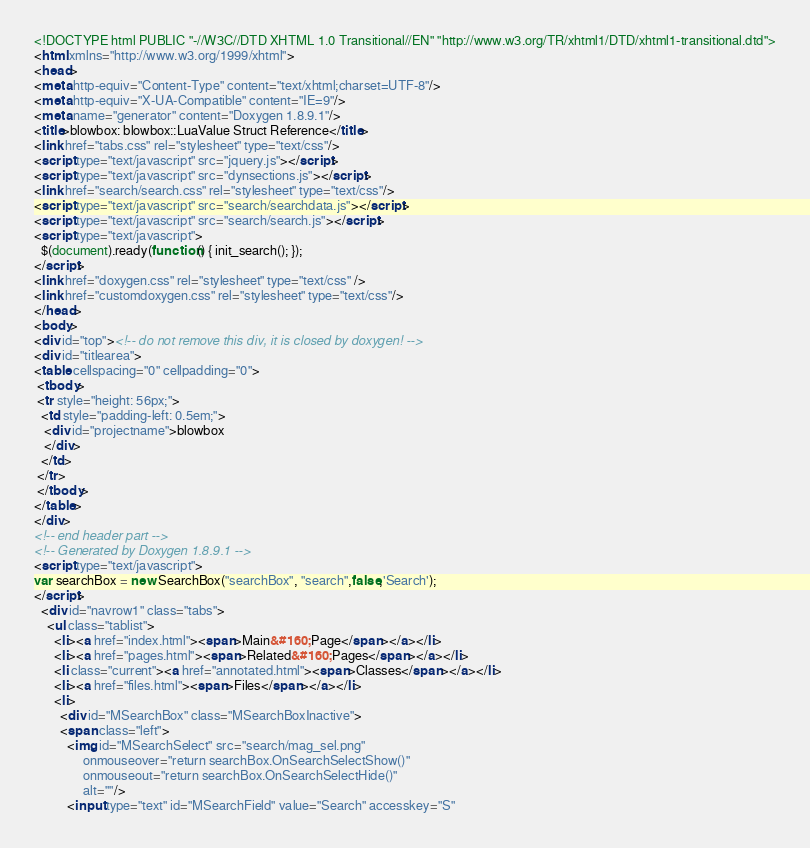Convert code to text. <code><loc_0><loc_0><loc_500><loc_500><_HTML_><!DOCTYPE html PUBLIC "-//W3C//DTD XHTML 1.0 Transitional//EN" "http://www.w3.org/TR/xhtml1/DTD/xhtml1-transitional.dtd">
<html xmlns="http://www.w3.org/1999/xhtml">
<head>
<meta http-equiv="Content-Type" content="text/xhtml;charset=UTF-8"/>
<meta http-equiv="X-UA-Compatible" content="IE=9"/>
<meta name="generator" content="Doxygen 1.8.9.1"/>
<title>blowbox: blowbox::LuaValue Struct Reference</title>
<link href="tabs.css" rel="stylesheet" type="text/css"/>
<script type="text/javascript" src="jquery.js"></script>
<script type="text/javascript" src="dynsections.js"></script>
<link href="search/search.css" rel="stylesheet" type="text/css"/>
<script type="text/javascript" src="search/searchdata.js"></script>
<script type="text/javascript" src="search/search.js"></script>
<script type="text/javascript">
  $(document).ready(function() { init_search(); });
</script>
<link href="doxygen.css" rel="stylesheet" type="text/css" />
<link href="customdoxygen.css" rel="stylesheet" type="text/css"/>
</head>
<body>
<div id="top"><!-- do not remove this div, it is closed by doxygen! -->
<div id="titlearea">
<table cellspacing="0" cellpadding="0">
 <tbody>
 <tr style="height: 56px;">
  <td style="padding-left: 0.5em;">
   <div id="projectname">blowbox
   </div>
  </td>
 </tr>
 </tbody>
</table>
</div>
<!-- end header part -->
<!-- Generated by Doxygen 1.8.9.1 -->
<script type="text/javascript">
var searchBox = new SearchBox("searchBox", "search",false,'Search');
</script>
  <div id="navrow1" class="tabs">
    <ul class="tablist">
      <li><a href="index.html"><span>Main&#160;Page</span></a></li>
      <li><a href="pages.html"><span>Related&#160;Pages</span></a></li>
      <li class="current"><a href="annotated.html"><span>Classes</span></a></li>
      <li><a href="files.html"><span>Files</span></a></li>
      <li>
        <div id="MSearchBox" class="MSearchBoxInactive">
        <span class="left">
          <img id="MSearchSelect" src="search/mag_sel.png"
               onmouseover="return searchBox.OnSearchSelectShow()"
               onmouseout="return searchBox.OnSearchSelectHide()"
               alt=""/>
          <input type="text" id="MSearchField" value="Search" accesskey="S"</code> 